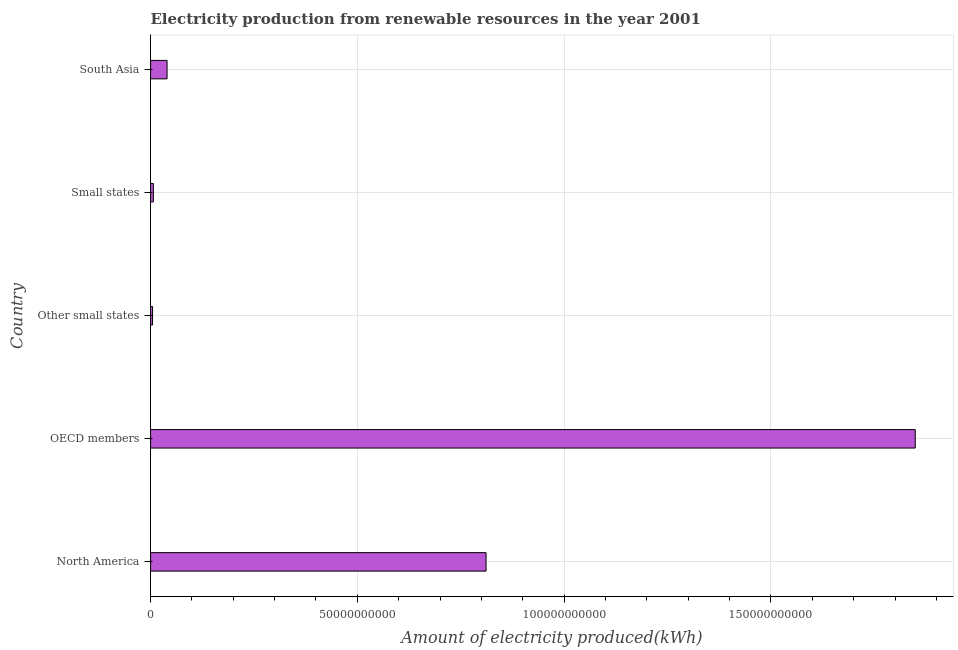Does the graph contain any zero values?
Offer a terse response. No. Does the graph contain grids?
Your answer should be very brief. Yes. What is the title of the graph?
Provide a short and direct response. Electricity production from renewable resources in the year 2001. What is the label or title of the X-axis?
Your response must be concise. Amount of electricity produced(kWh). What is the amount of electricity produced in South Asia?
Provide a succinct answer. 3.99e+09. Across all countries, what is the maximum amount of electricity produced?
Your answer should be compact. 1.85e+11. Across all countries, what is the minimum amount of electricity produced?
Ensure brevity in your answer.  4.85e+08. In which country was the amount of electricity produced maximum?
Your response must be concise. OECD members. In which country was the amount of electricity produced minimum?
Provide a short and direct response. Other small states. What is the sum of the amount of electricity produced?
Offer a terse response. 2.71e+11. What is the difference between the amount of electricity produced in OECD members and Other small states?
Your answer should be compact. 1.84e+11. What is the average amount of electricity produced per country?
Ensure brevity in your answer.  5.42e+1. What is the median amount of electricity produced?
Provide a short and direct response. 3.99e+09. In how many countries, is the amount of electricity produced greater than 110000000000 kWh?
Provide a short and direct response. 1. What is the ratio of the amount of electricity produced in North America to that in Small states?
Your answer should be very brief. 118.6. What is the difference between the highest and the second highest amount of electricity produced?
Your answer should be compact. 1.04e+11. Is the sum of the amount of electricity produced in North America and South Asia greater than the maximum amount of electricity produced across all countries?
Make the answer very short. No. What is the difference between the highest and the lowest amount of electricity produced?
Provide a short and direct response. 1.84e+11. Are all the bars in the graph horizontal?
Make the answer very short. Yes. What is the difference between two consecutive major ticks on the X-axis?
Offer a very short reply. 5.00e+1. What is the Amount of electricity produced(kWh) in North America?
Offer a terse response. 8.11e+1. What is the Amount of electricity produced(kWh) of OECD members?
Your answer should be very brief. 1.85e+11. What is the Amount of electricity produced(kWh) in Other small states?
Keep it short and to the point. 4.85e+08. What is the Amount of electricity produced(kWh) of Small states?
Your response must be concise. 6.84e+08. What is the Amount of electricity produced(kWh) of South Asia?
Keep it short and to the point. 3.99e+09. What is the difference between the Amount of electricity produced(kWh) in North America and OECD members?
Ensure brevity in your answer.  -1.04e+11. What is the difference between the Amount of electricity produced(kWh) in North America and Other small states?
Keep it short and to the point. 8.06e+1. What is the difference between the Amount of electricity produced(kWh) in North America and Small states?
Offer a very short reply. 8.04e+1. What is the difference between the Amount of electricity produced(kWh) in North America and South Asia?
Your response must be concise. 7.71e+1. What is the difference between the Amount of electricity produced(kWh) in OECD members and Other small states?
Offer a very short reply. 1.84e+11. What is the difference between the Amount of electricity produced(kWh) in OECD members and Small states?
Keep it short and to the point. 1.84e+11. What is the difference between the Amount of electricity produced(kWh) in OECD members and South Asia?
Your response must be concise. 1.81e+11. What is the difference between the Amount of electricity produced(kWh) in Other small states and Small states?
Ensure brevity in your answer.  -1.99e+08. What is the difference between the Amount of electricity produced(kWh) in Other small states and South Asia?
Give a very brief answer. -3.51e+09. What is the difference between the Amount of electricity produced(kWh) in Small states and South Asia?
Make the answer very short. -3.31e+09. What is the ratio of the Amount of electricity produced(kWh) in North America to that in OECD members?
Your response must be concise. 0.44. What is the ratio of the Amount of electricity produced(kWh) in North America to that in Other small states?
Your response must be concise. 167.26. What is the ratio of the Amount of electricity produced(kWh) in North America to that in Small states?
Give a very brief answer. 118.6. What is the ratio of the Amount of electricity produced(kWh) in North America to that in South Asia?
Give a very brief answer. 20.31. What is the ratio of the Amount of electricity produced(kWh) in OECD members to that in Other small states?
Provide a short and direct response. 381.21. What is the ratio of the Amount of electricity produced(kWh) in OECD members to that in Small states?
Provide a succinct answer. 270.3. What is the ratio of the Amount of electricity produced(kWh) in OECD members to that in South Asia?
Keep it short and to the point. 46.29. What is the ratio of the Amount of electricity produced(kWh) in Other small states to that in Small states?
Offer a terse response. 0.71. What is the ratio of the Amount of electricity produced(kWh) in Other small states to that in South Asia?
Your response must be concise. 0.12. What is the ratio of the Amount of electricity produced(kWh) in Small states to that in South Asia?
Your response must be concise. 0.17. 